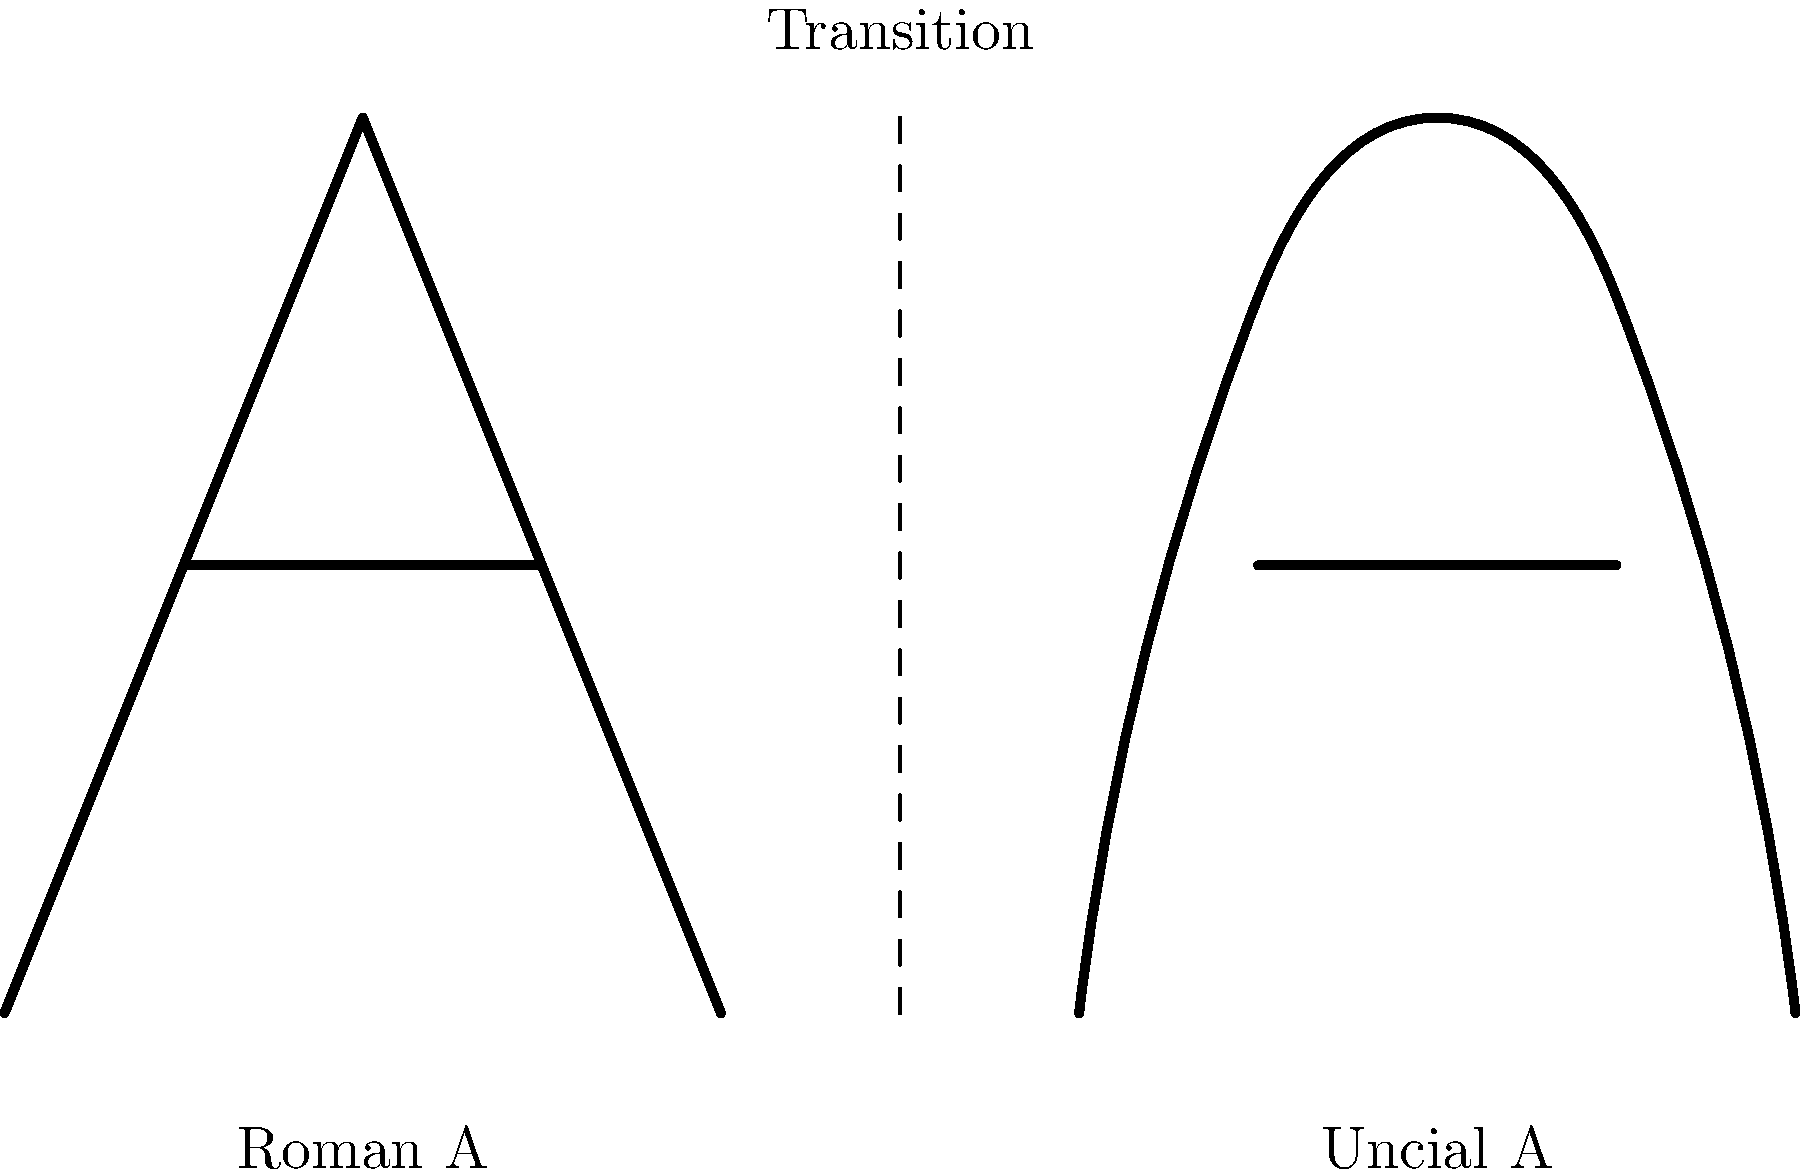Analyze the angular changes in the letterform of 'A' during the transition from Roman inscriptions to uncial manuscripts. What key transformation occurred in the shape of the letter, and how might this reflect changes in writing technology and scribal practices? To understand the angular changes in the letterform of 'A' during the transition from Roman inscriptions to uncial manuscripts, we need to examine the graphic closely:

1. Roman capital 'A':
   - Consists of two straight lines meeting at a sharp point at the top
   - Has a horizontal crossbar
   - Characterized by angular, geometric forms

2. Uncial 'A':
   - Features curved lines instead of straight ones
   - The top is rounded rather than pointed
   - Still retains a horizontal crossbar, but it's integrated into a more fluid shape

3. Key transformations:
   - Straight lines become curves
   - Sharp angles are replaced by rounded forms
   - Overall shape becomes more fluid and less geometric

4. Reasons for these changes:
   - Transition from stone carving to writing on parchment or papyrus
   - Shift from using chisels to using quills or reed pens
   - Need for faster, more efficient writing in manuscript production

5. Implications:
   - Curves are easier and quicker to produce with a pen than sharp angles
   - Rounded forms flow more naturally in continuous writing
   - Changes reflect an adaptation to new writing surfaces and tools

The transformation from angular to curved forms in the letter 'A' exemplifies a broader shift in writing practices, moving from the rigid, monumental style of inscriptions to the more fluid, efficient style needed for manuscript production.
Answer: Angularity to curvature, reflecting shift from stone carving to pen writing 